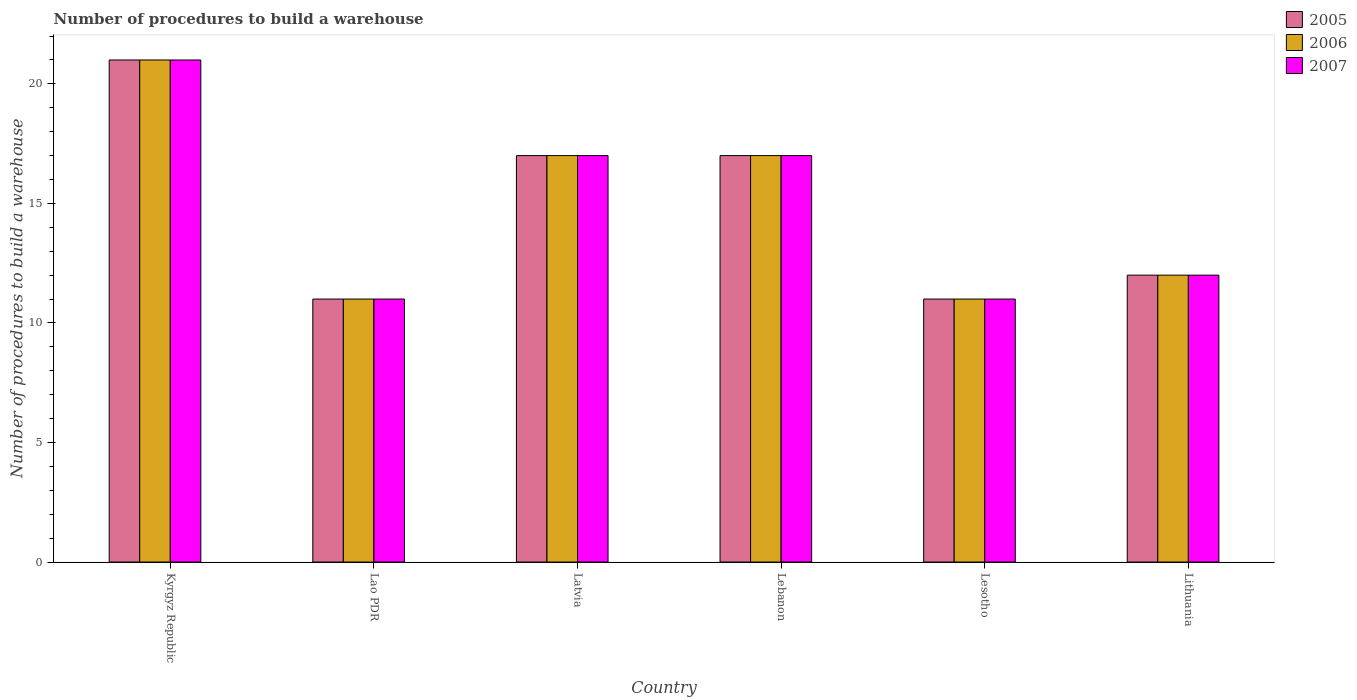How many bars are there on the 1st tick from the left?
Keep it short and to the point. 3. What is the label of the 6th group of bars from the left?
Offer a terse response. Lithuania. What is the number of procedures to build a warehouse in in 2007 in Lithuania?
Give a very brief answer. 12. Across all countries, what is the minimum number of procedures to build a warehouse in in 2005?
Your answer should be very brief. 11. In which country was the number of procedures to build a warehouse in in 2006 maximum?
Give a very brief answer. Kyrgyz Republic. In which country was the number of procedures to build a warehouse in in 2007 minimum?
Offer a very short reply. Lao PDR. What is the total number of procedures to build a warehouse in in 2005 in the graph?
Your answer should be very brief. 89. What is the difference between the number of procedures to build a warehouse in in 2005 in Lebanon and the number of procedures to build a warehouse in in 2007 in Latvia?
Ensure brevity in your answer.  0. What is the average number of procedures to build a warehouse in in 2007 per country?
Offer a very short reply. 14.83. What is the difference between the number of procedures to build a warehouse in of/in 2006 and number of procedures to build a warehouse in of/in 2005 in Lithuania?
Provide a short and direct response. 0. In how many countries, is the number of procedures to build a warehouse in in 2006 greater than 3?
Keep it short and to the point. 6. What is the ratio of the number of procedures to build a warehouse in in 2007 in Lao PDR to that in Lesotho?
Make the answer very short. 1. Is the difference between the number of procedures to build a warehouse in in 2006 in Latvia and Lesotho greater than the difference between the number of procedures to build a warehouse in in 2005 in Latvia and Lesotho?
Make the answer very short. No. What is the difference between the highest and the lowest number of procedures to build a warehouse in in 2007?
Offer a terse response. 10. What does the 2nd bar from the left in Latvia represents?
Offer a very short reply. 2006. What does the 2nd bar from the right in Lebanon represents?
Give a very brief answer. 2006. Is it the case that in every country, the sum of the number of procedures to build a warehouse in in 2007 and number of procedures to build a warehouse in in 2006 is greater than the number of procedures to build a warehouse in in 2005?
Give a very brief answer. Yes. How many bars are there?
Provide a short and direct response. 18. Are all the bars in the graph horizontal?
Offer a very short reply. No. How many countries are there in the graph?
Provide a short and direct response. 6. Does the graph contain any zero values?
Keep it short and to the point. No. How many legend labels are there?
Provide a succinct answer. 3. What is the title of the graph?
Provide a short and direct response. Number of procedures to build a warehouse. Does "1976" appear as one of the legend labels in the graph?
Offer a very short reply. No. What is the label or title of the Y-axis?
Offer a terse response. Number of procedures to build a warehouse. What is the Number of procedures to build a warehouse in 2005 in Kyrgyz Republic?
Your response must be concise. 21. What is the Number of procedures to build a warehouse of 2006 in Lao PDR?
Give a very brief answer. 11. What is the Number of procedures to build a warehouse in 2006 in Lebanon?
Give a very brief answer. 17. What is the Number of procedures to build a warehouse of 2005 in Lesotho?
Give a very brief answer. 11. What is the Number of procedures to build a warehouse of 2006 in Lesotho?
Offer a very short reply. 11. What is the Number of procedures to build a warehouse of 2005 in Lithuania?
Offer a very short reply. 12. Across all countries, what is the maximum Number of procedures to build a warehouse in 2005?
Ensure brevity in your answer.  21. Across all countries, what is the maximum Number of procedures to build a warehouse in 2007?
Offer a very short reply. 21. Across all countries, what is the minimum Number of procedures to build a warehouse of 2005?
Give a very brief answer. 11. Across all countries, what is the minimum Number of procedures to build a warehouse of 2006?
Your answer should be compact. 11. What is the total Number of procedures to build a warehouse of 2005 in the graph?
Your answer should be compact. 89. What is the total Number of procedures to build a warehouse of 2006 in the graph?
Give a very brief answer. 89. What is the total Number of procedures to build a warehouse in 2007 in the graph?
Offer a very short reply. 89. What is the difference between the Number of procedures to build a warehouse in 2005 in Kyrgyz Republic and that in Lao PDR?
Make the answer very short. 10. What is the difference between the Number of procedures to build a warehouse of 2007 in Kyrgyz Republic and that in Lao PDR?
Keep it short and to the point. 10. What is the difference between the Number of procedures to build a warehouse of 2005 in Kyrgyz Republic and that in Lesotho?
Keep it short and to the point. 10. What is the difference between the Number of procedures to build a warehouse of 2006 in Kyrgyz Republic and that in Lesotho?
Ensure brevity in your answer.  10. What is the difference between the Number of procedures to build a warehouse in 2007 in Kyrgyz Republic and that in Lesotho?
Your response must be concise. 10. What is the difference between the Number of procedures to build a warehouse of 2005 in Kyrgyz Republic and that in Lithuania?
Provide a succinct answer. 9. What is the difference between the Number of procedures to build a warehouse in 2006 in Kyrgyz Republic and that in Lithuania?
Provide a short and direct response. 9. What is the difference between the Number of procedures to build a warehouse of 2007 in Kyrgyz Republic and that in Lithuania?
Make the answer very short. 9. What is the difference between the Number of procedures to build a warehouse of 2005 in Lao PDR and that in Lebanon?
Offer a terse response. -6. What is the difference between the Number of procedures to build a warehouse in 2006 in Lao PDR and that in Lebanon?
Ensure brevity in your answer.  -6. What is the difference between the Number of procedures to build a warehouse of 2005 in Lao PDR and that in Lesotho?
Offer a very short reply. 0. What is the difference between the Number of procedures to build a warehouse in 2006 in Lao PDR and that in Lesotho?
Your response must be concise. 0. What is the difference between the Number of procedures to build a warehouse in 2006 in Lao PDR and that in Lithuania?
Provide a short and direct response. -1. What is the difference between the Number of procedures to build a warehouse in 2007 in Latvia and that in Lebanon?
Your answer should be very brief. 0. What is the difference between the Number of procedures to build a warehouse in 2005 in Latvia and that in Lesotho?
Provide a succinct answer. 6. What is the difference between the Number of procedures to build a warehouse of 2006 in Latvia and that in Lesotho?
Keep it short and to the point. 6. What is the difference between the Number of procedures to build a warehouse of 2005 in Lebanon and that in Lesotho?
Offer a terse response. 6. What is the difference between the Number of procedures to build a warehouse of 2006 in Lebanon and that in Lesotho?
Make the answer very short. 6. What is the difference between the Number of procedures to build a warehouse in 2007 in Lebanon and that in Lesotho?
Give a very brief answer. 6. What is the difference between the Number of procedures to build a warehouse of 2005 in Lebanon and that in Lithuania?
Your answer should be very brief. 5. What is the difference between the Number of procedures to build a warehouse in 2006 in Lebanon and that in Lithuania?
Your response must be concise. 5. What is the difference between the Number of procedures to build a warehouse of 2006 in Lesotho and that in Lithuania?
Provide a succinct answer. -1. What is the difference between the Number of procedures to build a warehouse of 2005 in Kyrgyz Republic and the Number of procedures to build a warehouse of 2006 in Lao PDR?
Give a very brief answer. 10. What is the difference between the Number of procedures to build a warehouse in 2005 in Kyrgyz Republic and the Number of procedures to build a warehouse in 2006 in Latvia?
Your answer should be very brief. 4. What is the difference between the Number of procedures to build a warehouse of 2005 in Kyrgyz Republic and the Number of procedures to build a warehouse of 2007 in Latvia?
Provide a short and direct response. 4. What is the difference between the Number of procedures to build a warehouse of 2006 in Kyrgyz Republic and the Number of procedures to build a warehouse of 2007 in Latvia?
Provide a short and direct response. 4. What is the difference between the Number of procedures to build a warehouse in 2005 in Kyrgyz Republic and the Number of procedures to build a warehouse in 2007 in Lebanon?
Ensure brevity in your answer.  4. What is the difference between the Number of procedures to build a warehouse of 2006 in Kyrgyz Republic and the Number of procedures to build a warehouse of 2007 in Lebanon?
Make the answer very short. 4. What is the difference between the Number of procedures to build a warehouse of 2005 in Kyrgyz Republic and the Number of procedures to build a warehouse of 2006 in Lesotho?
Offer a very short reply. 10. What is the difference between the Number of procedures to build a warehouse of 2005 in Kyrgyz Republic and the Number of procedures to build a warehouse of 2007 in Lesotho?
Offer a very short reply. 10. What is the difference between the Number of procedures to build a warehouse in 2006 in Kyrgyz Republic and the Number of procedures to build a warehouse in 2007 in Lesotho?
Provide a short and direct response. 10. What is the difference between the Number of procedures to build a warehouse in 2005 in Kyrgyz Republic and the Number of procedures to build a warehouse in 2006 in Lithuania?
Provide a succinct answer. 9. What is the difference between the Number of procedures to build a warehouse of 2006 in Kyrgyz Republic and the Number of procedures to build a warehouse of 2007 in Lithuania?
Provide a short and direct response. 9. What is the difference between the Number of procedures to build a warehouse in 2006 in Lao PDR and the Number of procedures to build a warehouse in 2007 in Latvia?
Your answer should be compact. -6. What is the difference between the Number of procedures to build a warehouse in 2005 in Lao PDR and the Number of procedures to build a warehouse in 2006 in Lebanon?
Your answer should be compact. -6. What is the difference between the Number of procedures to build a warehouse in 2005 in Lao PDR and the Number of procedures to build a warehouse in 2007 in Lebanon?
Your answer should be very brief. -6. What is the difference between the Number of procedures to build a warehouse in 2005 in Lao PDR and the Number of procedures to build a warehouse in 2006 in Lesotho?
Give a very brief answer. 0. What is the difference between the Number of procedures to build a warehouse of 2005 in Lao PDR and the Number of procedures to build a warehouse of 2007 in Lesotho?
Your response must be concise. 0. What is the difference between the Number of procedures to build a warehouse of 2005 in Lao PDR and the Number of procedures to build a warehouse of 2006 in Lithuania?
Provide a short and direct response. -1. What is the difference between the Number of procedures to build a warehouse of 2006 in Lao PDR and the Number of procedures to build a warehouse of 2007 in Lithuania?
Offer a very short reply. -1. What is the difference between the Number of procedures to build a warehouse of 2006 in Latvia and the Number of procedures to build a warehouse of 2007 in Lebanon?
Provide a short and direct response. 0. What is the difference between the Number of procedures to build a warehouse of 2005 in Latvia and the Number of procedures to build a warehouse of 2007 in Lesotho?
Ensure brevity in your answer.  6. What is the difference between the Number of procedures to build a warehouse of 2006 in Latvia and the Number of procedures to build a warehouse of 2007 in Lesotho?
Offer a terse response. 6. What is the difference between the Number of procedures to build a warehouse in 2005 in Latvia and the Number of procedures to build a warehouse in 2006 in Lithuania?
Your response must be concise. 5. What is the difference between the Number of procedures to build a warehouse in 2005 in Latvia and the Number of procedures to build a warehouse in 2007 in Lithuania?
Offer a terse response. 5. What is the difference between the Number of procedures to build a warehouse of 2005 in Lebanon and the Number of procedures to build a warehouse of 2006 in Lesotho?
Give a very brief answer. 6. What is the difference between the Number of procedures to build a warehouse of 2006 in Lebanon and the Number of procedures to build a warehouse of 2007 in Lesotho?
Make the answer very short. 6. What is the difference between the Number of procedures to build a warehouse in 2005 in Lebanon and the Number of procedures to build a warehouse in 2006 in Lithuania?
Your answer should be very brief. 5. What is the difference between the Number of procedures to build a warehouse of 2005 in Lebanon and the Number of procedures to build a warehouse of 2007 in Lithuania?
Make the answer very short. 5. What is the difference between the Number of procedures to build a warehouse in 2005 in Lesotho and the Number of procedures to build a warehouse in 2006 in Lithuania?
Make the answer very short. -1. What is the average Number of procedures to build a warehouse in 2005 per country?
Make the answer very short. 14.83. What is the average Number of procedures to build a warehouse of 2006 per country?
Make the answer very short. 14.83. What is the average Number of procedures to build a warehouse of 2007 per country?
Keep it short and to the point. 14.83. What is the difference between the Number of procedures to build a warehouse in 2005 and Number of procedures to build a warehouse in 2006 in Kyrgyz Republic?
Offer a very short reply. 0. What is the difference between the Number of procedures to build a warehouse in 2006 and Number of procedures to build a warehouse in 2007 in Lao PDR?
Provide a succinct answer. 0. What is the difference between the Number of procedures to build a warehouse of 2005 and Number of procedures to build a warehouse of 2006 in Latvia?
Your answer should be very brief. 0. What is the difference between the Number of procedures to build a warehouse in 2006 and Number of procedures to build a warehouse in 2007 in Latvia?
Your answer should be very brief. 0. What is the difference between the Number of procedures to build a warehouse of 2005 and Number of procedures to build a warehouse of 2006 in Lebanon?
Provide a short and direct response. 0. What is the difference between the Number of procedures to build a warehouse in 2006 and Number of procedures to build a warehouse in 2007 in Lesotho?
Your answer should be compact. 0. What is the difference between the Number of procedures to build a warehouse in 2005 and Number of procedures to build a warehouse in 2006 in Lithuania?
Offer a terse response. 0. What is the difference between the Number of procedures to build a warehouse in 2006 and Number of procedures to build a warehouse in 2007 in Lithuania?
Ensure brevity in your answer.  0. What is the ratio of the Number of procedures to build a warehouse of 2005 in Kyrgyz Republic to that in Lao PDR?
Give a very brief answer. 1.91. What is the ratio of the Number of procedures to build a warehouse in 2006 in Kyrgyz Republic to that in Lao PDR?
Your response must be concise. 1.91. What is the ratio of the Number of procedures to build a warehouse in 2007 in Kyrgyz Republic to that in Lao PDR?
Offer a very short reply. 1.91. What is the ratio of the Number of procedures to build a warehouse in 2005 in Kyrgyz Republic to that in Latvia?
Keep it short and to the point. 1.24. What is the ratio of the Number of procedures to build a warehouse of 2006 in Kyrgyz Republic to that in Latvia?
Your answer should be compact. 1.24. What is the ratio of the Number of procedures to build a warehouse of 2007 in Kyrgyz Republic to that in Latvia?
Your answer should be compact. 1.24. What is the ratio of the Number of procedures to build a warehouse in 2005 in Kyrgyz Republic to that in Lebanon?
Give a very brief answer. 1.24. What is the ratio of the Number of procedures to build a warehouse in 2006 in Kyrgyz Republic to that in Lebanon?
Make the answer very short. 1.24. What is the ratio of the Number of procedures to build a warehouse in 2007 in Kyrgyz Republic to that in Lebanon?
Offer a very short reply. 1.24. What is the ratio of the Number of procedures to build a warehouse in 2005 in Kyrgyz Republic to that in Lesotho?
Your answer should be compact. 1.91. What is the ratio of the Number of procedures to build a warehouse in 2006 in Kyrgyz Republic to that in Lesotho?
Your response must be concise. 1.91. What is the ratio of the Number of procedures to build a warehouse in 2007 in Kyrgyz Republic to that in Lesotho?
Your answer should be very brief. 1.91. What is the ratio of the Number of procedures to build a warehouse of 2005 in Kyrgyz Republic to that in Lithuania?
Offer a terse response. 1.75. What is the ratio of the Number of procedures to build a warehouse of 2007 in Kyrgyz Republic to that in Lithuania?
Your response must be concise. 1.75. What is the ratio of the Number of procedures to build a warehouse of 2005 in Lao PDR to that in Latvia?
Provide a short and direct response. 0.65. What is the ratio of the Number of procedures to build a warehouse of 2006 in Lao PDR to that in Latvia?
Offer a very short reply. 0.65. What is the ratio of the Number of procedures to build a warehouse in 2007 in Lao PDR to that in Latvia?
Ensure brevity in your answer.  0.65. What is the ratio of the Number of procedures to build a warehouse of 2005 in Lao PDR to that in Lebanon?
Your response must be concise. 0.65. What is the ratio of the Number of procedures to build a warehouse of 2006 in Lao PDR to that in Lebanon?
Provide a succinct answer. 0.65. What is the ratio of the Number of procedures to build a warehouse of 2007 in Lao PDR to that in Lebanon?
Your answer should be very brief. 0.65. What is the ratio of the Number of procedures to build a warehouse of 2006 in Lao PDR to that in Lesotho?
Ensure brevity in your answer.  1. What is the ratio of the Number of procedures to build a warehouse of 2007 in Lao PDR to that in Lesotho?
Ensure brevity in your answer.  1. What is the ratio of the Number of procedures to build a warehouse in 2005 in Lao PDR to that in Lithuania?
Ensure brevity in your answer.  0.92. What is the ratio of the Number of procedures to build a warehouse of 2006 in Lao PDR to that in Lithuania?
Provide a succinct answer. 0.92. What is the ratio of the Number of procedures to build a warehouse in 2005 in Latvia to that in Lesotho?
Offer a terse response. 1.55. What is the ratio of the Number of procedures to build a warehouse in 2006 in Latvia to that in Lesotho?
Provide a succinct answer. 1.55. What is the ratio of the Number of procedures to build a warehouse in 2007 in Latvia to that in Lesotho?
Ensure brevity in your answer.  1.55. What is the ratio of the Number of procedures to build a warehouse in 2005 in Latvia to that in Lithuania?
Offer a very short reply. 1.42. What is the ratio of the Number of procedures to build a warehouse in 2006 in Latvia to that in Lithuania?
Keep it short and to the point. 1.42. What is the ratio of the Number of procedures to build a warehouse in 2007 in Latvia to that in Lithuania?
Ensure brevity in your answer.  1.42. What is the ratio of the Number of procedures to build a warehouse of 2005 in Lebanon to that in Lesotho?
Ensure brevity in your answer.  1.55. What is the ratio of the Number of procedures to build a warehouse in 2006 in Lebanon to that in Lesotho?
Your response must be concise. 1.55. What is the ratio of the Number of procedures to build a warehouse in 2007 in Lebanon to that in Lesotho?
Offer a very short reply. 1.55. What is the ratio of the Number of procedures to build a warehouse of 2005 in Lebanon to that in Lithuania?
Offer a very short reply. 1.42. What is the ratio of the Number of procedures to build a warehouse in 2006 in Lebanon to that in Lithuania?
Your answer should be very brief. 1.42. What is the ratio of the Number of procedures to build a warehouse in 2007 in Lebanon to that in Lithuania?
Offer a very short reply. 1.42. What is the difference between the highest and the second highest Number of procedures to build a warehouse in 2006?
Offer a very short reply. 4. 